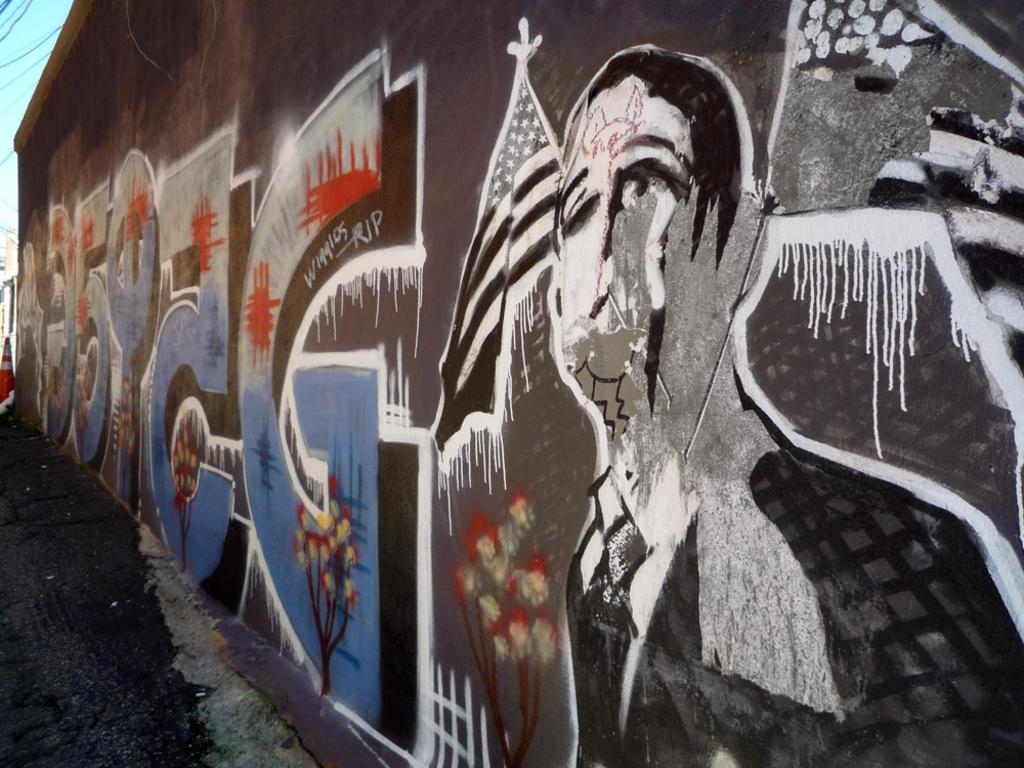What is on the wall in the image? There is a wall with text and images in the image. Can you describe the text on the wall? Unfortunately, the facts provided do not give any information about the text on the wall. What can be seen on the ground in the image? The ground is visible in the image, but the facts do not specify what is on the ground. What objects are on the left side of the image? The facts mention that there are objects on the left side of the image, but their specific nature is not described. How many cacti are present on the left side of the image? There is no mention of cacti in the provided facts, so we cannot determine their presence or quantity in the image. What type of shoes can be seen on the wall in the image? There is no mention of shoes in the provided facts, so we cannot determine their presence or type in the image. 